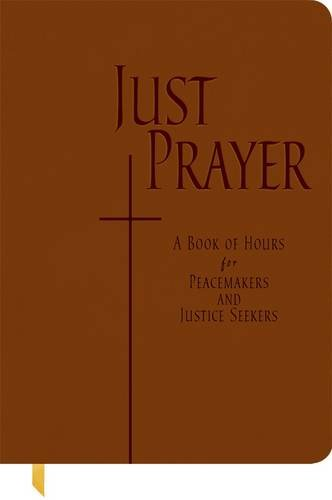What is the title of this book? The book is titled 'Just Prayer: A Book of Hours for Peacemakers and Justice Seekers', a guide aimed at fostering peace and justice through prayer. 